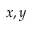Convert formula to latex. <formula><loc_0><loc_0><loc_500><loc_500>x , y</formula> 